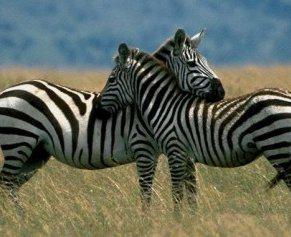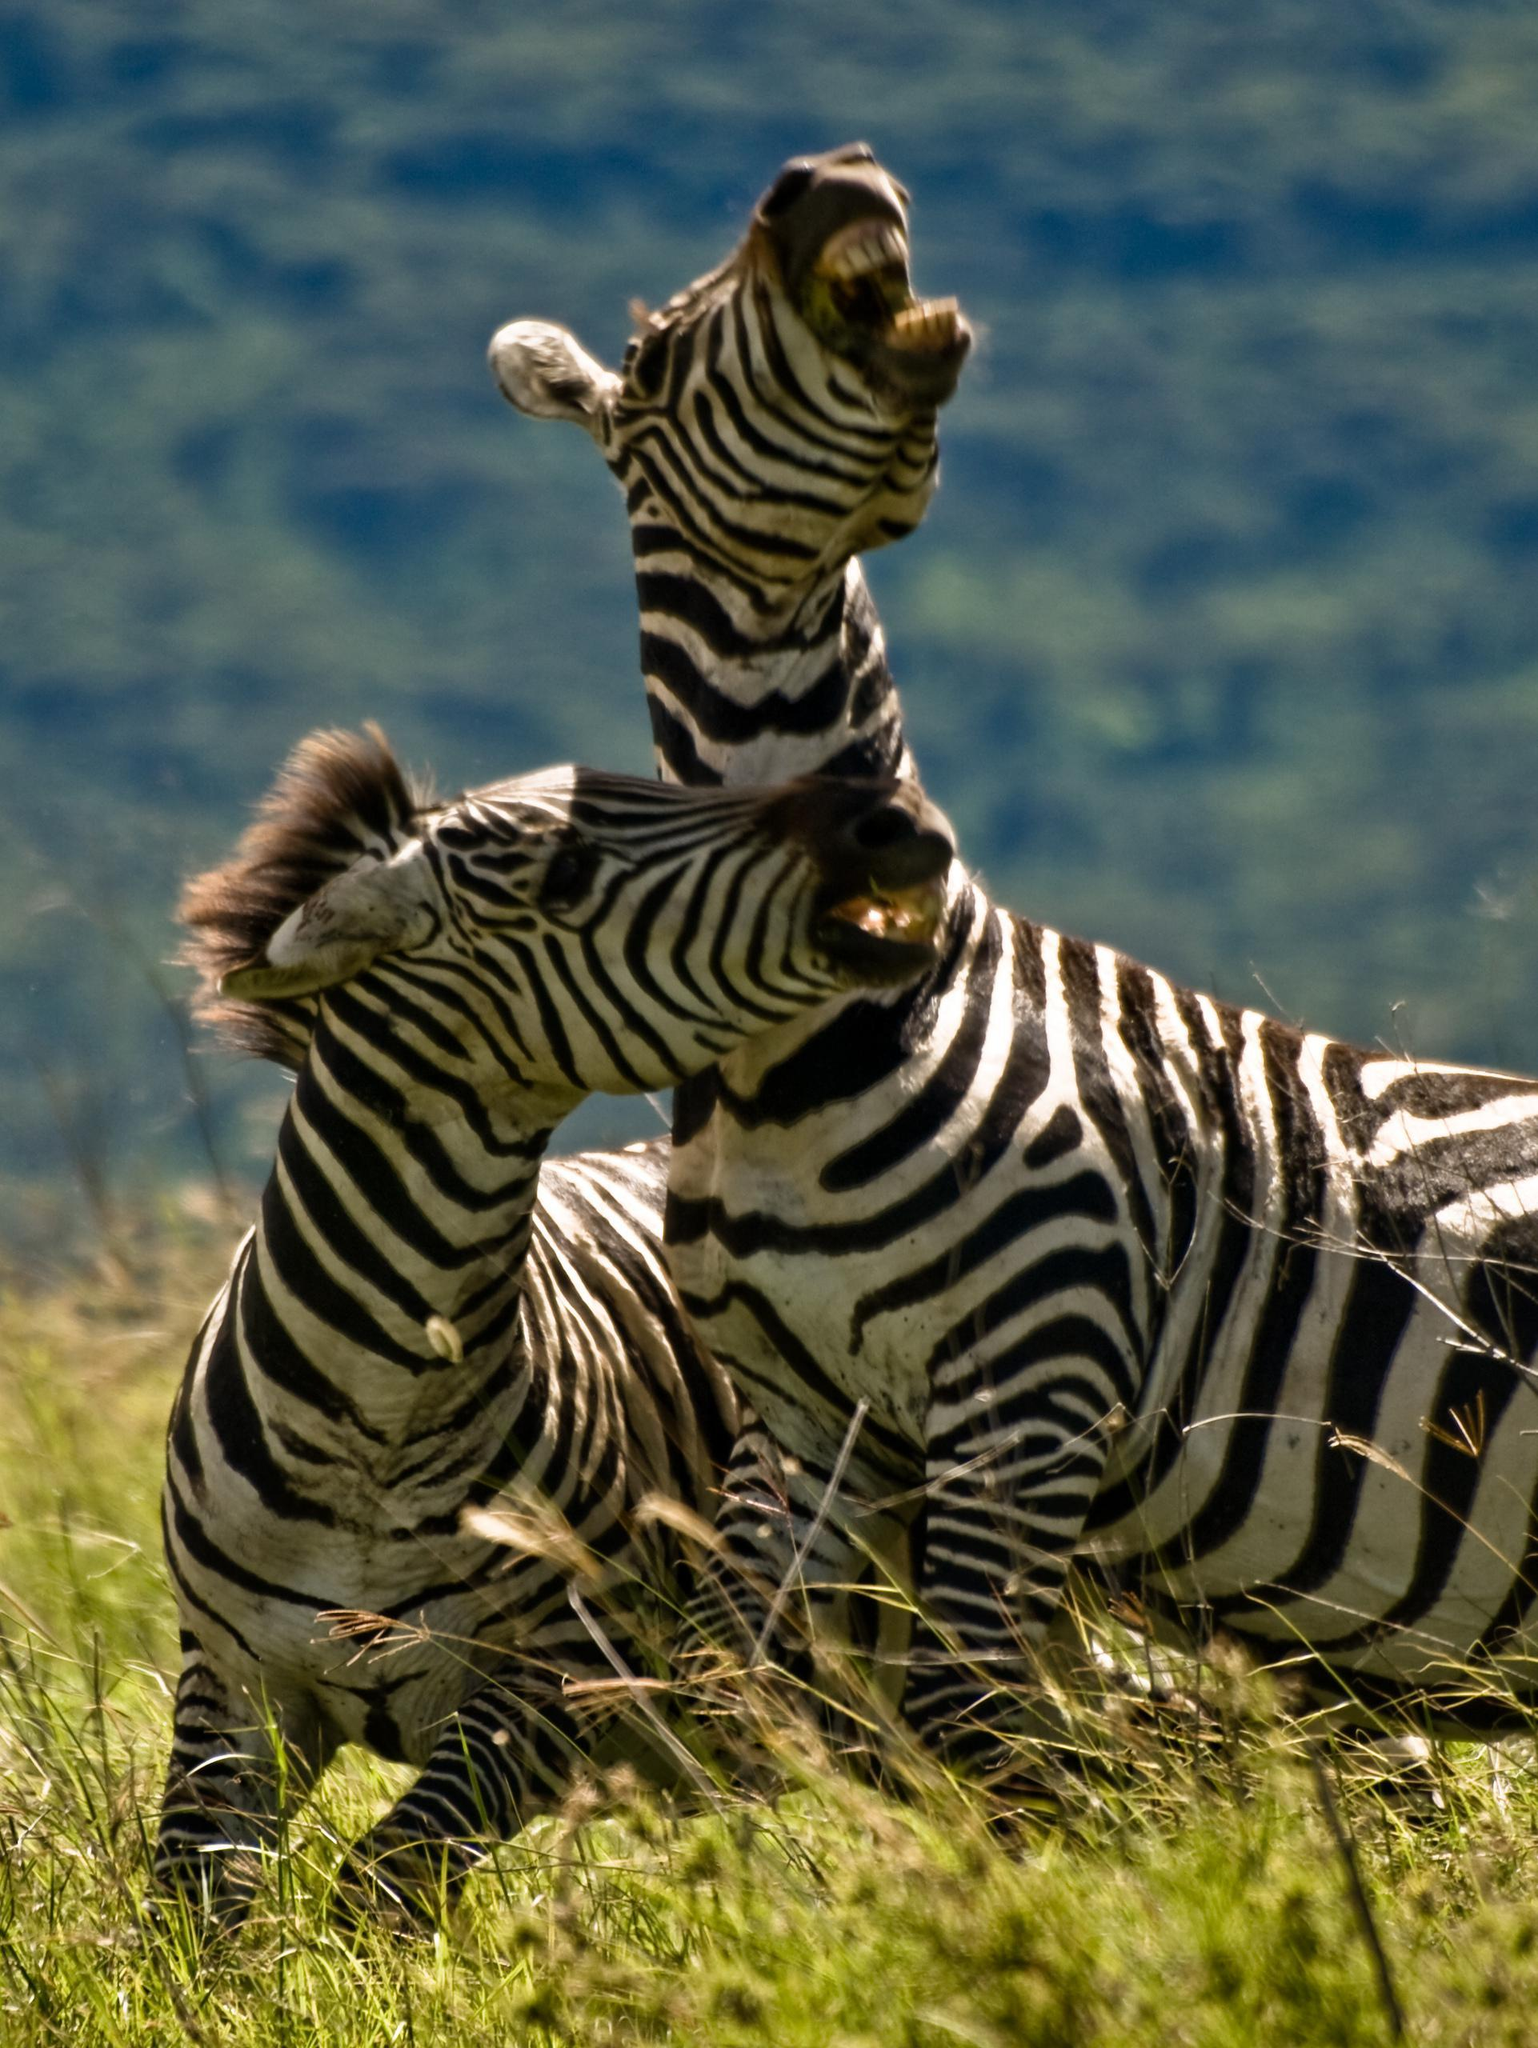The first image is the image on the left, the second image is the image on the right. Evaluate the accuracy of this statement regarding the images: "Each picture shows exactly two zebras.". Is it true? Answer yes or no. Yes. 